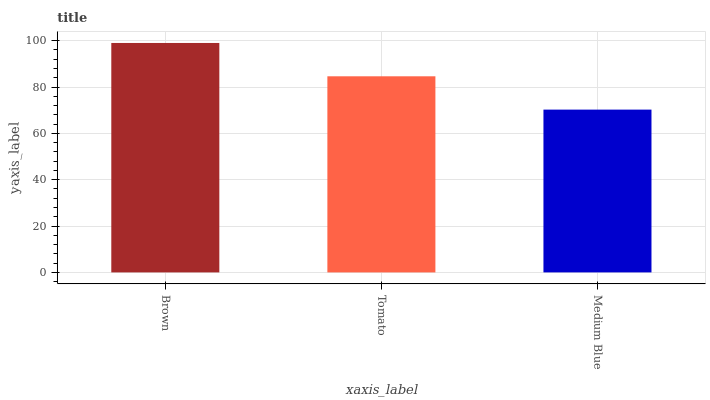Is Medium Blue the minimum?
Answer yes or no. Yes. Is Brown the maximum?
Answer yes or no. Yes. Is Tomato the minimum?
Answer yes or no. No. Is Tomato the maximum?
Answer yes or no. No. Is Brown greater than Tomato?
Answer yes or no. Yes. Is Tomato less than Brown?
Answer yes or no. Yes. Is Tomato greater than Brown?
Answer yes or no. No. Is Brown less than Tomato?
Answer yes or no. No. Is Tomato the high median?
Answer yes or no. Yes. Is Tomato the low median?
Answer yes or no. Yes. Is Medium Blue the high median?
Answer yes or no. No. Is Medium Blue the low median?
Answer yes or no. No. 